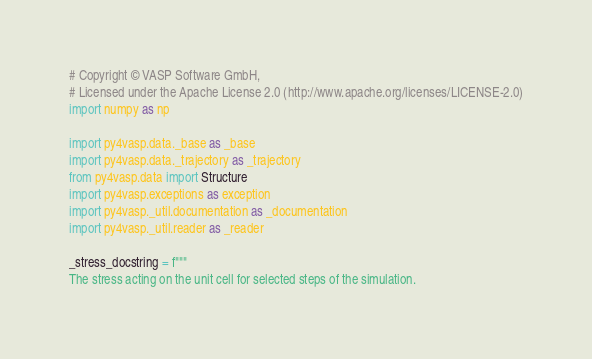Convert code to text. <code><loc_0><loc_0><loc_500><loc_500><_Python_># Copyright © VASP Software GmbH,
# Licensed under the Apache License 2.0 (http://www.apache.org/licenses/LICENSE-2.0)
import numpy as np

import py4vasp.data._base as _base
import py4vasp.data._trajectory as _trajectory
from py4vasp.data import Structure
import py4vasp.exceptions as exception
import py4vasp._util.documentation as _documentation
import py4vasp._util.reader as _reader

_stress_docstring = f"""
The stress acting on the unit cell for selected steps of the simulation.
</code> 